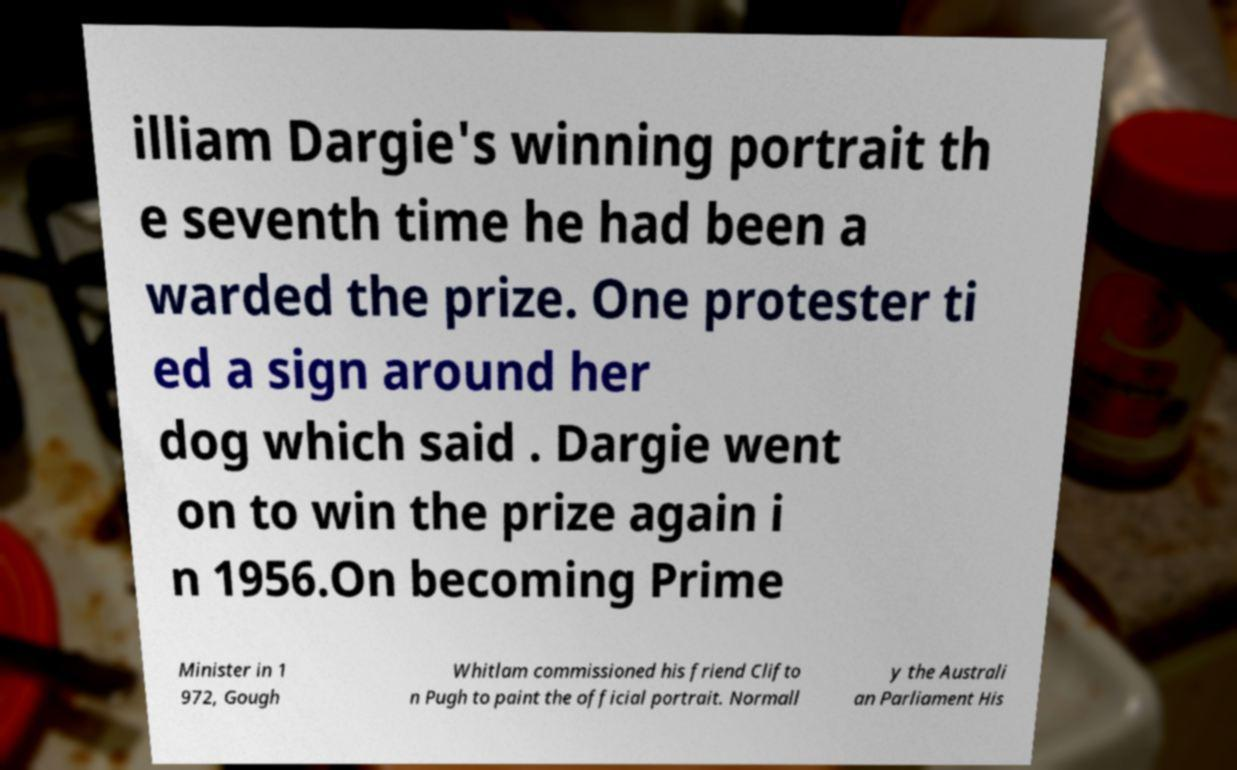Please identify and transcribe the text found in this image. illiam Dargie's winning portrait th e seventh time he had been a warded the prize. One protester ti ed a sign around her dog which said . Dargie went on to win the prize again i n 1956.On becoming Prime Minister in 1 972, Gough Whitlam commissioned his friend Clifto n Pugh to paint the official portrait. Normall y the Australi an Parliament His 